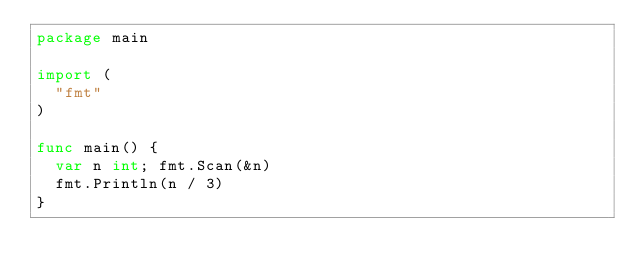Convert code to text. <code><loc_0><loc_0><loc_500><loc_500><_Go_>package main

import (
  "fmt"
)

func main() {
  var n int; fmt.Scan(&n)
  fmt.Println(n / 3)
}</code> 